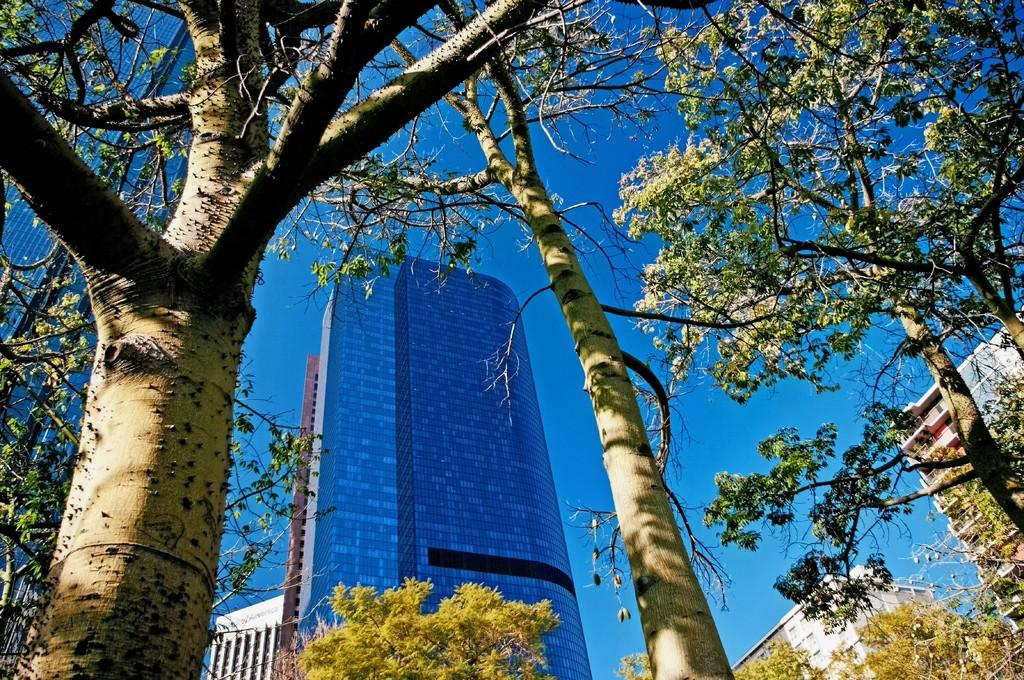What type of structures can be seen in the image? There are buildings in the image. What other natural elements are present in the image? There are trees in the image. What can be seen in the distance in the image? The sky is visible in the background of the image. What type of government is depicted in the image? There is no indication of a government in the image; it primarily features buildings, trees, and the sky. 